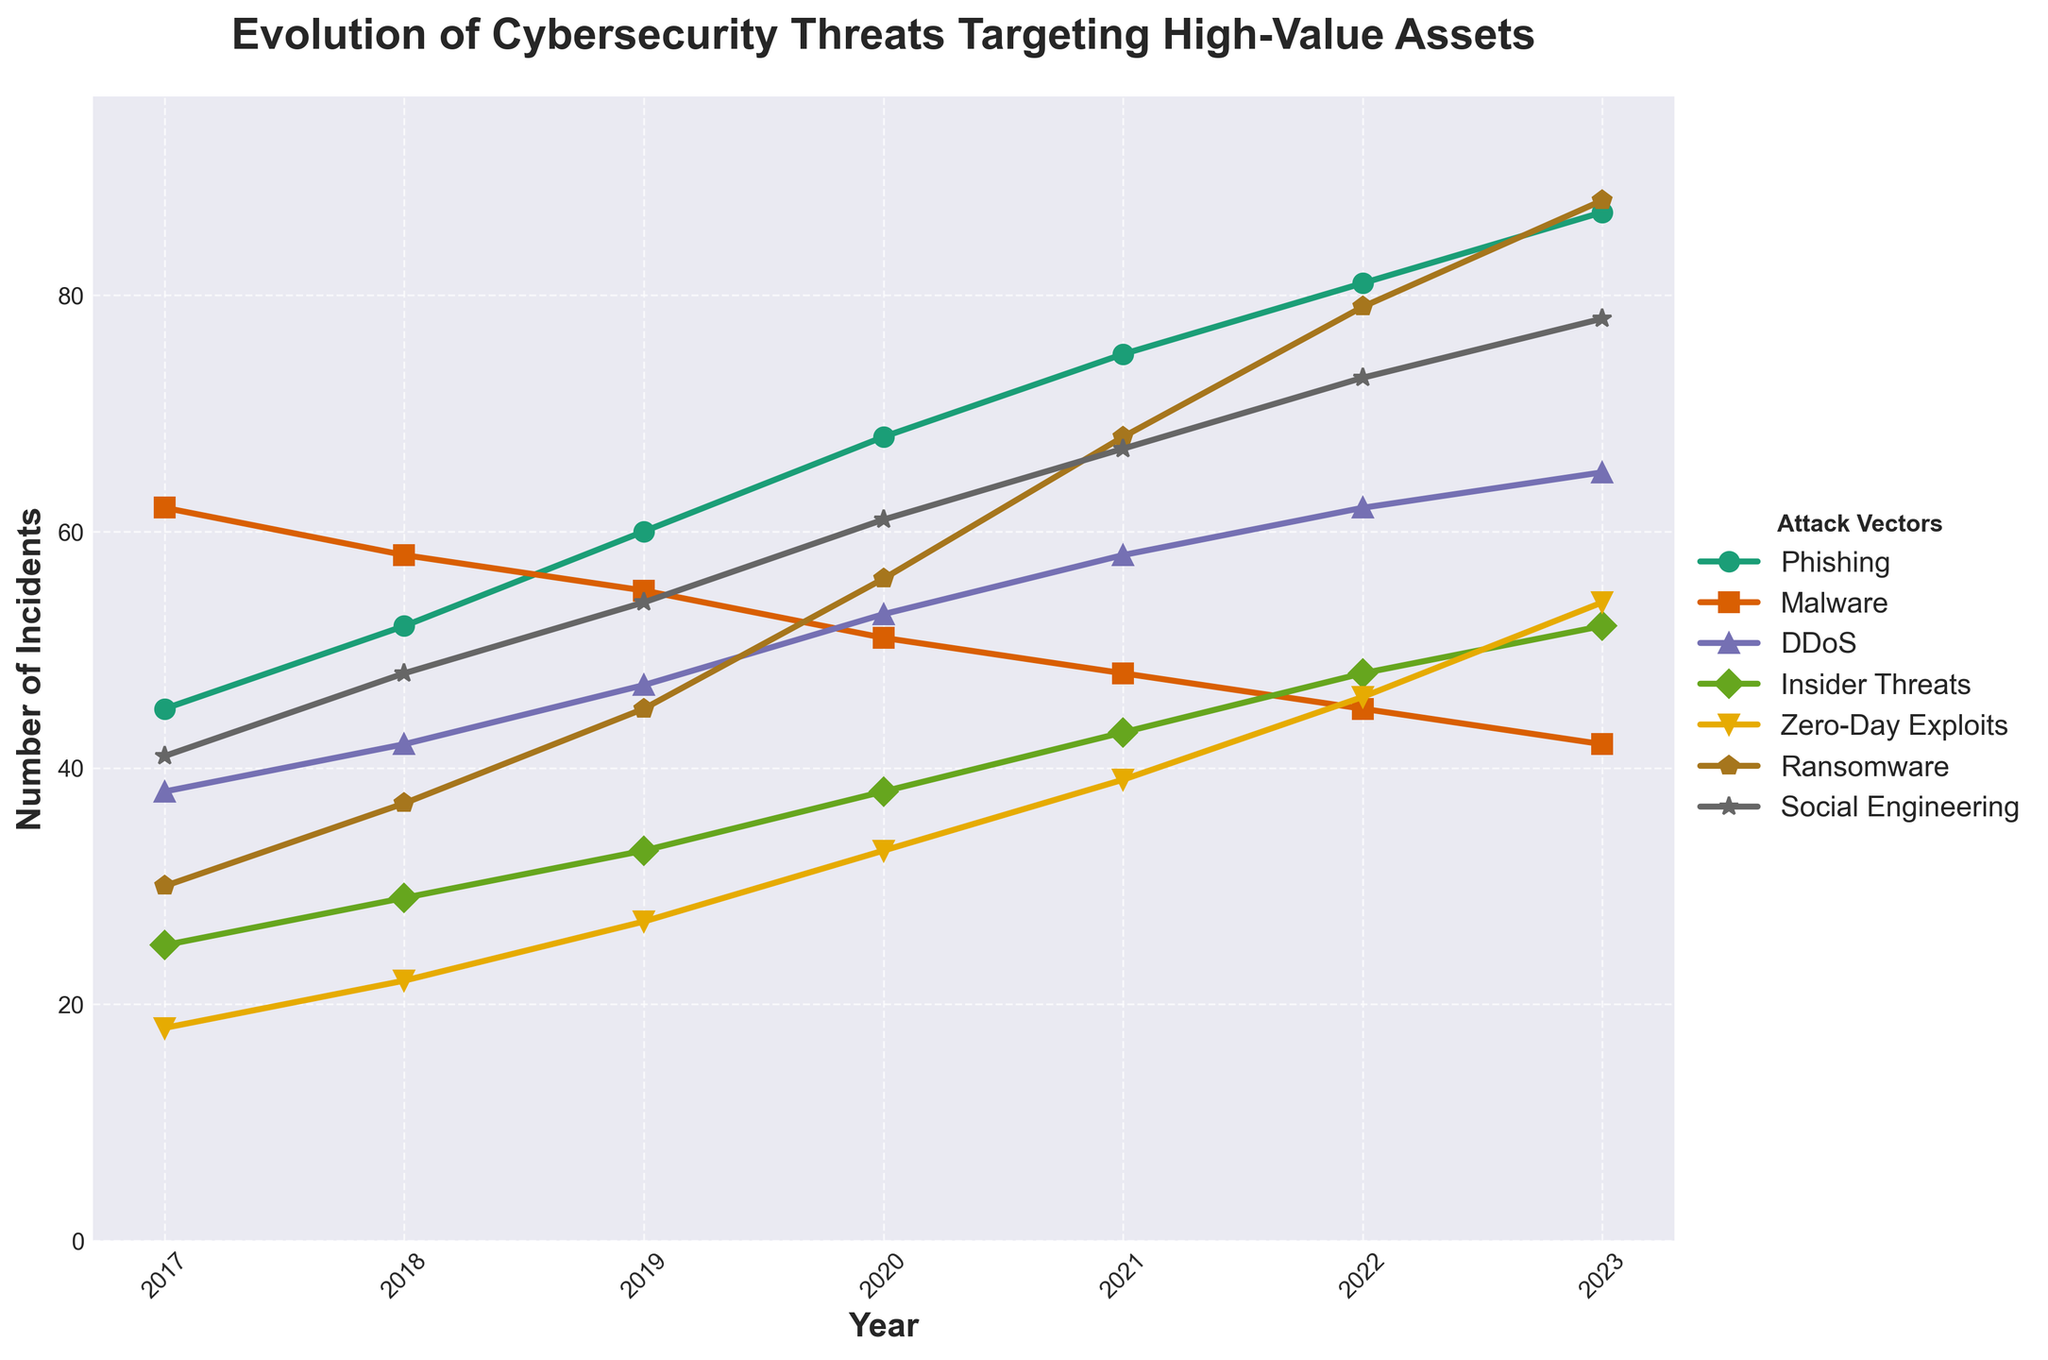What is the trend in the number of phishing incidents from 2017 to 2023? Observe that the line representing Phishing is increasing over the years from 45 incidents in 2017 to 87 incidents in 2023.
Answer: Increasing Which attack vector had the highest number of incidents in 2023? Check the highest point in 2023 across all attack vectors; Ransomware had the highest count with 88 incidents.
Answer: Ransomware How many more DDoS incidents were there in 2023 compared to 2017? Subtract the number of DDoS incidents in 2017 (38) from those in 2023 (65). Differences are calculated as 65 - 38.
Answer: 27 Between 2017 and 2023, which attack vector showed the largest increase in the number of incidents? Calculate the difference in the number of incidents for each attack vector between 2017 and 2023. Ransomware increased from 30 in 2017 to 88 in 2023, an increase of 58 incidents, which is the largest.
Answer: Ransomware Which two attack vectors had an equal number of incidents in any given year? Check for equal values between different pairs of attack vectors across the years. For example, in 2022, Malware and DDoS both had 62 incidents.
Answer: Malware and DDoS in 2022 In which year did Insider Threats surpass 40 incidents for the first time? Identify the first year when the Insider Threats line passes the 40 mark on the y-axis. This happened in 2021.
Answer: 2021 What was the average number of incidents of Zero-Day Exploits from 2017 to 2023? Sum the incident counts for Zero-Day Exploits over all years (18+22+27+33+39+46+54) and divide by 7. The total is 239, so the average is 239/7.
Answer: 34.14 Which attack vector decreased every year between 2017 and 2023? Examine the trends for each attack vector to identify any that consistently decrease. Malware shows a consistent decrease from 62 incidents in 2017 to 42 incidents in 2023.
Answer: Malware Compare the incidence of Social Engineering in 2018 and 2023. What is the difference? Subtract the number of Social Engineering incidents in 2018 (48) from those in 2023 (78). The difference is 78 - 48.
Answer: 30 What is the combined number of incidents for Ransomware and Zero-Day Exploits in 2023? Add the number of Ransomware incidents (88) and Zero-Day Exploits incidents (54) in 2023. The combined count is 88 + 54.
Answer: 142 